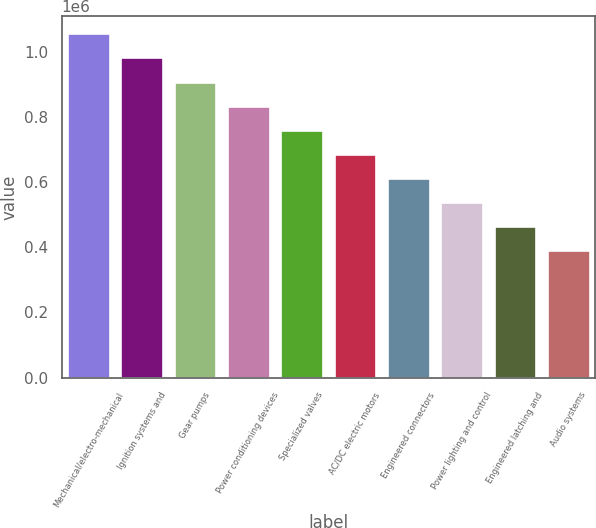<chart> <loc_0><loc_0><loc_500><loc_500><bar_chart><fcel>Mechanical/electro-mechanical<fcel>Ignition systems and<fcel>Gear pumps<fcel>Power conditioning devices<fcel>Specialized valves<fcel>AC/DC electric motors<fcel>Engineered connectors<fcel>Power lighting and control<fcel>Engineered latching and<fcel>Audio systems<nl><fcel>1.0574e+06<fcel>983434<fcel>909474<fcel>835513<fcel>761552<fcel>687591<fcel>613630<fcel>539670<fcel>465709<fcel>391748<nl></chart> 